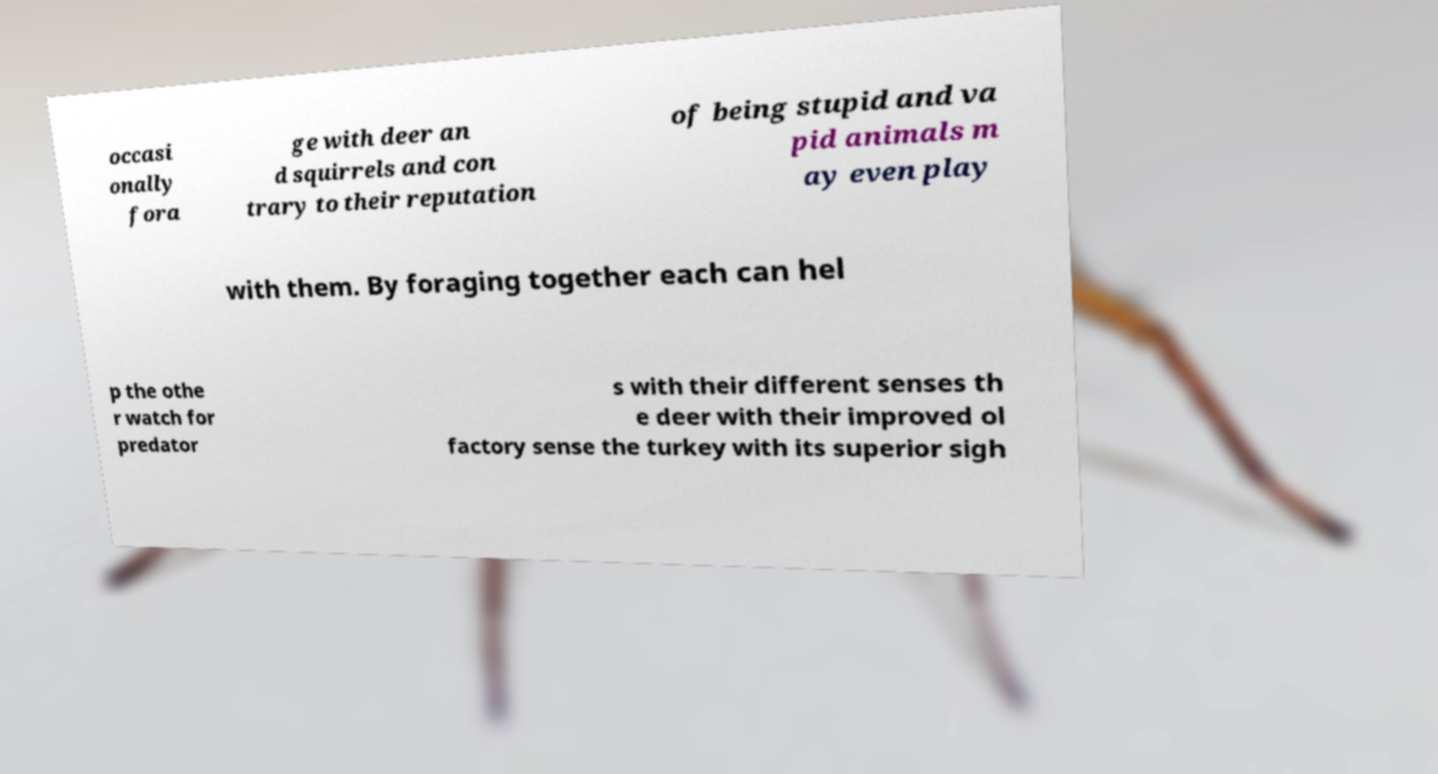Please read and relay the text visible in this image. What does it say? occasi onally fora ge with deer an d squirrels and con trary to their reputation of being stupid and va pid animals m ay even play with them. By foraging together each can hel p the othe r watch for predator s with their different senses th e deer with their improved ol factory sense the turkey with its superior sigh 